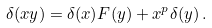Convert formula to latex. <formula><loc_0><loc_0><loc_500><loc_500>\delta ( x y ) = \delta ( x ) F ( y ) + x ^ { p } \delta ( y ) \, .</formula> 